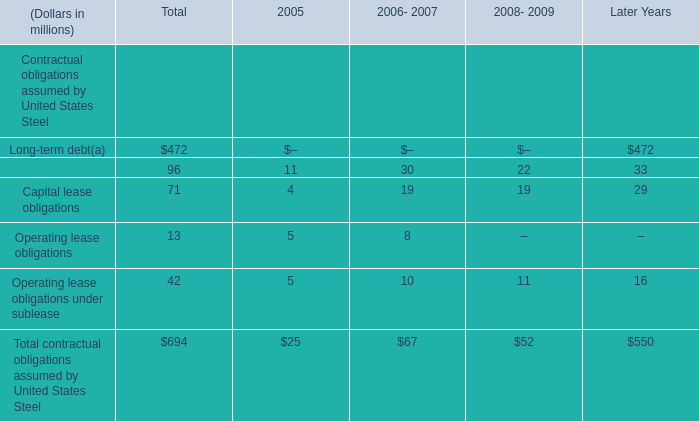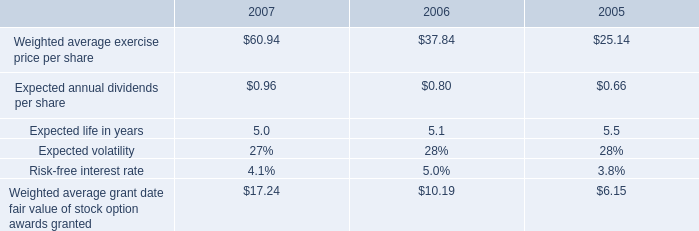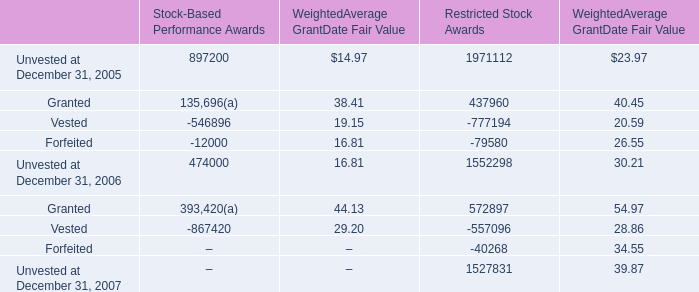by how much did the weighted average exercise price per share increase from 2005 to 2007? 
Computations: ((60.94 - 25.14) / 25.14)
Answer: 1.42403. 